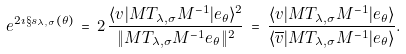Convert formula to latex. <formula><loc_0><loc_0><loc_500><loc_500>e ^ { 2 \imath \S s _ { \lambda , \sigma } ( \theta ) } \, = \, 2 \, \frac { \langle v | M T _ { \lambda , \sigma } M ^ { - 1 } | e _ { \theta } \rangle ^ { 2 } } { \| M T _ { \lambda , \sigma } M ^ { - 1 } e _ { \theta } \| ^ { 2 } } \, = \, \frac { \langle v | M T _ { \lambda , \sigma } M ^ { - 1 } | e _ { \theta } \rangle } { \langle \overline { v } | M T _ { \lambda , \sigma } M ^ { - 1 } | e _ { \theta } \rangle } .</formula> 